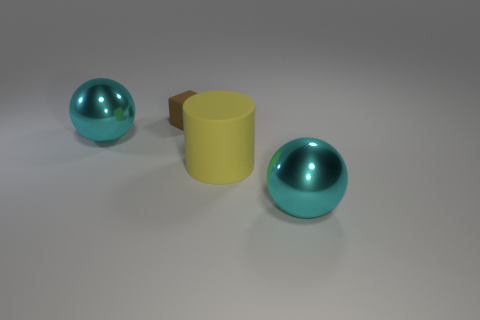Add 1 cubes. How many objects exist? 5 Subtract all cylinders. How many objects are left? 3 Subtract all yellow matte objects. Subtract all small brown rubber cubes. How many objects are left? 2 Add 4 large yellow rubber cylinders. How many large yellow rubber cylinders are left? 5 Add 2 cyan metallic cubes. How many cyan metallic cubes exist? 2 Subtract 2 cyan balls. How many objects are left? 2 